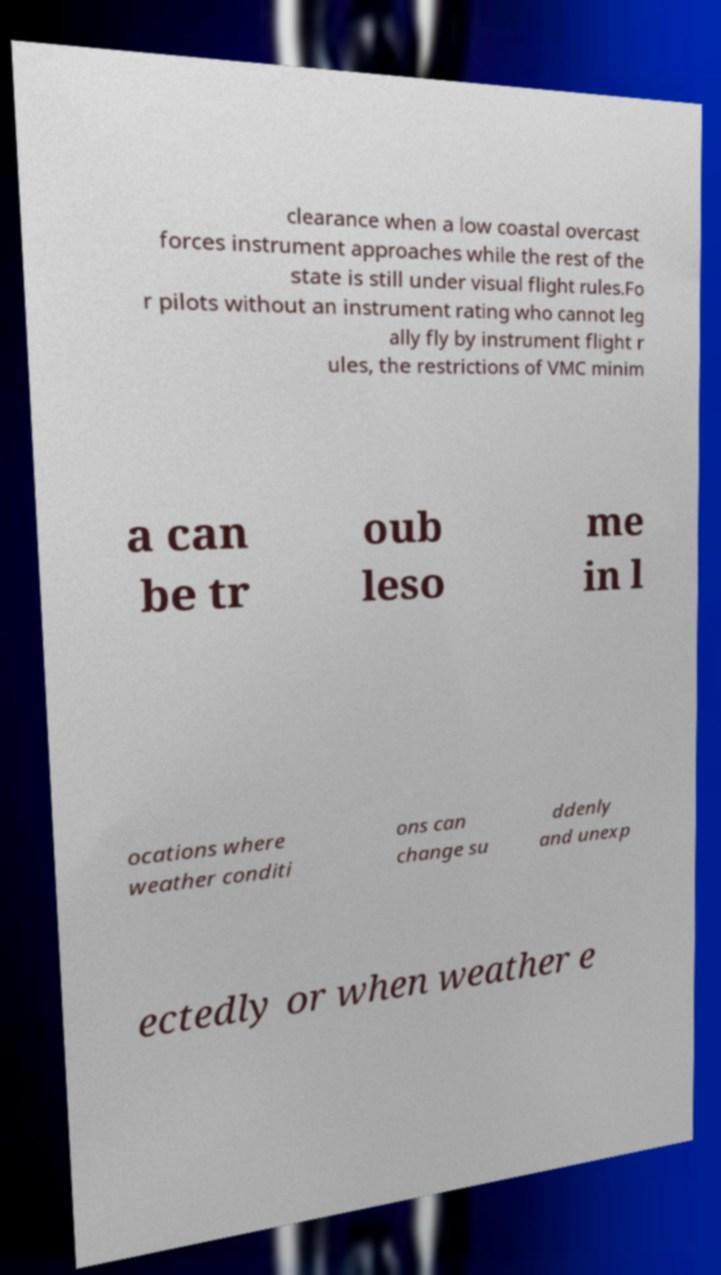Can you accurately transcribe the text from the provided image for me? clearance when a low coastal overcast forces instrument approaches while the rest of the state is still under visual flight rules.Fo r pilots without an instrument rating who cannot leg ally fly by instrument flight r ules, the restrictions of VMC minim a can be tr oub leso me in l ocations where weather conditi ons can change su ddenly and unexp ectedly or when weather e 